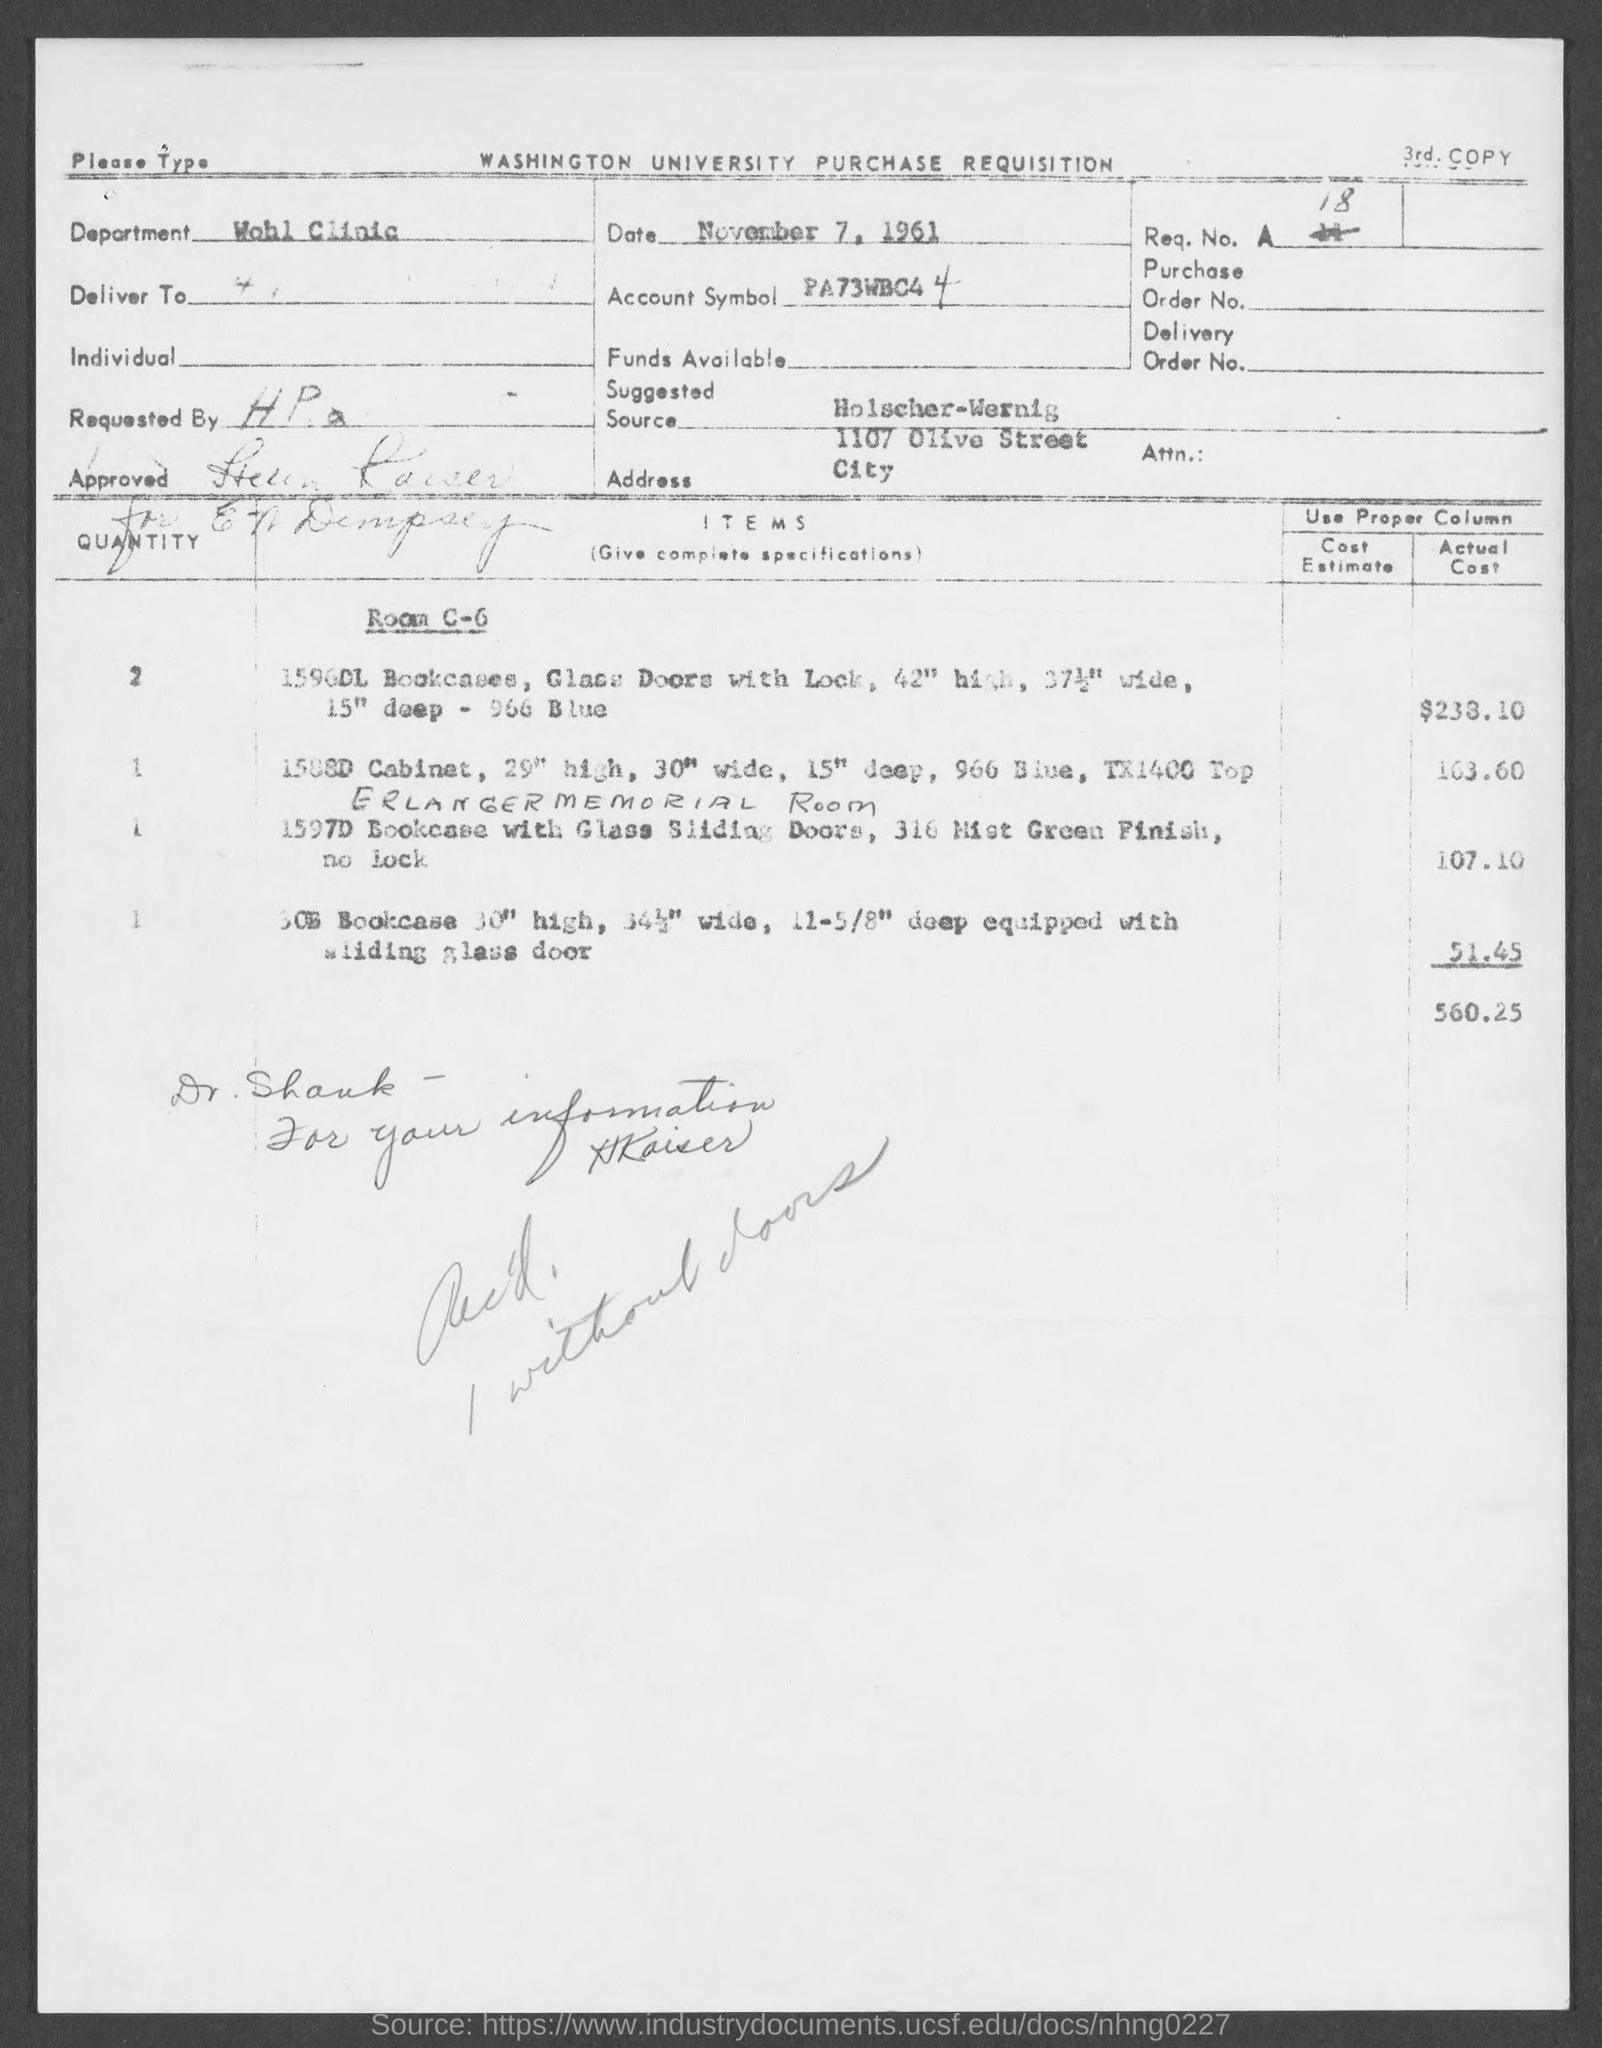What is the date on the document?
Provide a succinct answer. November 7, 1961. What is the department?
Offer a terse response. Wohl Clinic. What is the suggested source?
Offer a very short reply. Holscher-Wernig. 